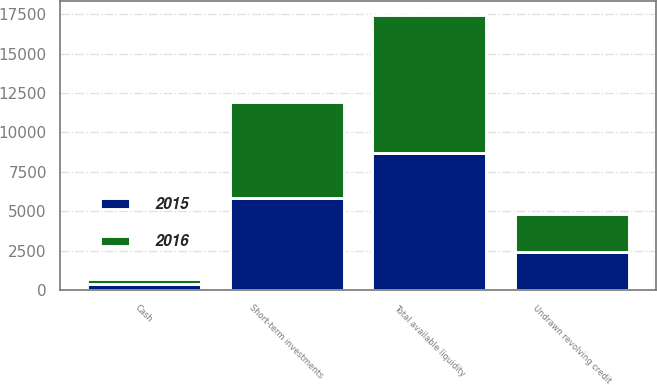Convert chart. <chart><loc_0><loc_0><loc_500><loc_500><stacked_bar_chart><ecel><fcel>Cash<fcel>Short-term investments<fcel>Undrawn revolving credit<fcel>Total available liquidity<nl><fcel>2016<fcel>322<fcel>6037<fcel>2425<fcel>8784<nl><fcel>2015<fcel>390<fcel>5864<fcel>2425<fcel>8679<nl></chart> 